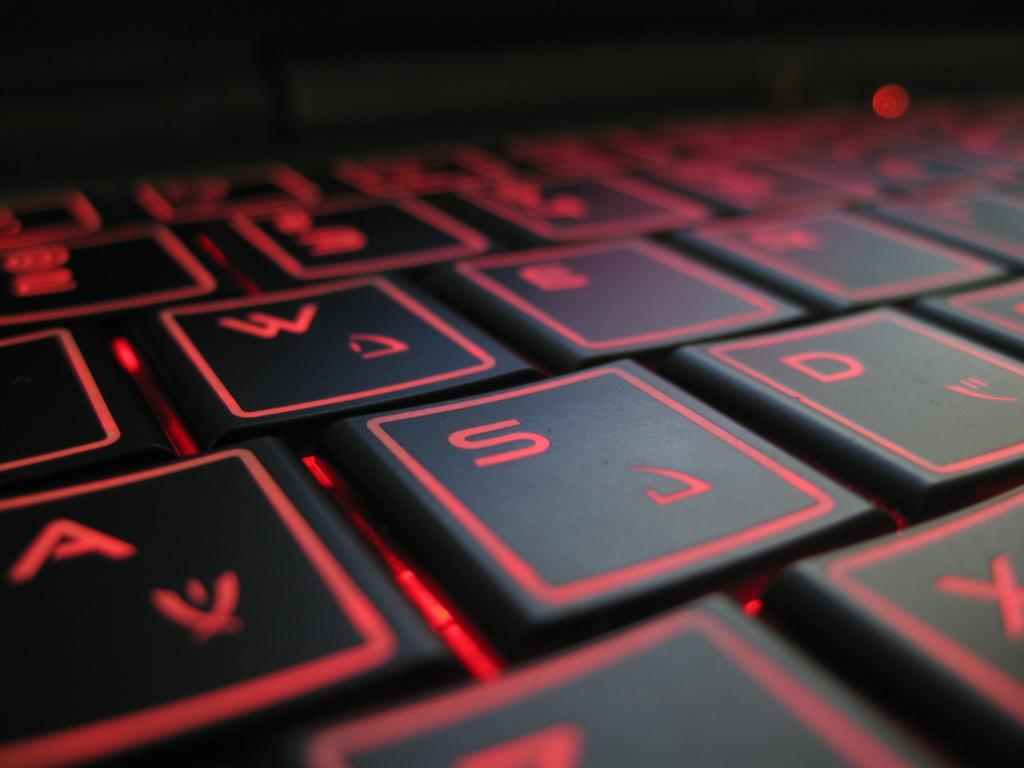<image>
Give a short and clear explanation of the subsequent image. A black and red keyboard zoomed in on the keys a, s, and d. 